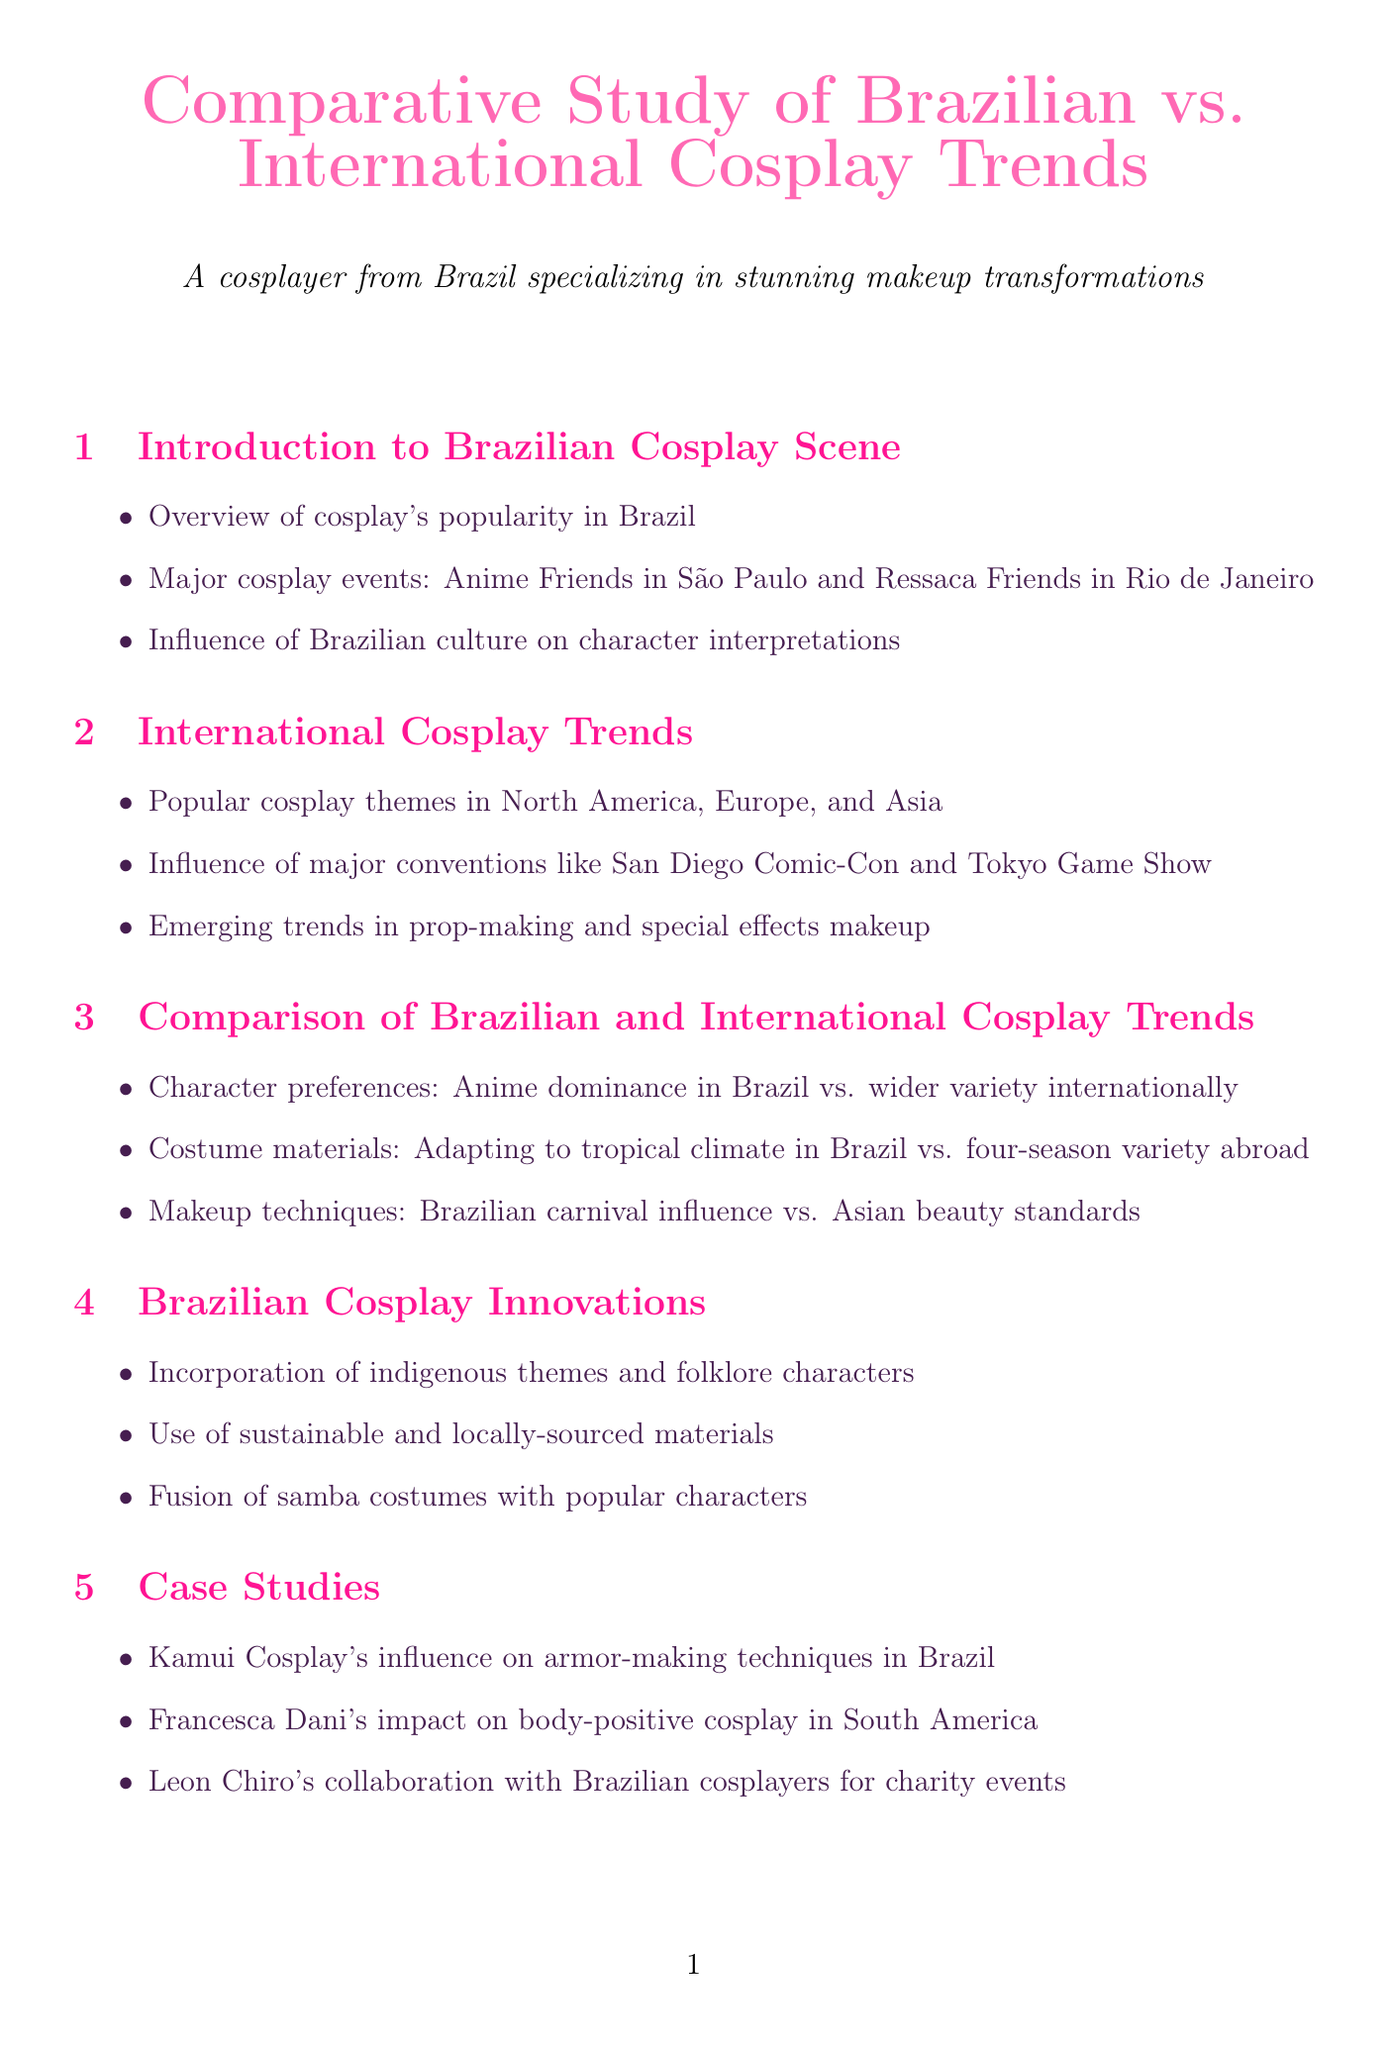What is the main event in São Paulo? The report mentions Anime Friends as the major cosplay event in São Paulo.
Answer: Anime Friends What percentage of Brazilian cosplayers prefer anime characters? The report states that 65% of Brazilian cosplayers prefer anime characters.
Answer: 65% Who is the author of "Makeup Artistry in Cosplay: From Hollywood to São Paulo"? The document lists Carlos Mendez as the author of this publication.
Answer: Carlos Mendez What is the average spend on a cosplay costume in Brazil? The average cost mentioned for a cosplay costume in Brazil is R$500.
Answer: R$500 Which major convention is a significant influence on international cosplay trends? The report highlights San Diego Comic-Con as a key influence on international cosplay trends.
Answer: San Diego Comic-Con What unique cultural element do Brazilian cosplayers incorporate into their costumes? Brazilian cosplayers are noted for incorporating indigenous themes and folklore characters into their costumes.
Answer: Indigenous themes What is the potential for Brazilian comic book characters according to the report? The document suggests there is potential for Brazilian comic book characters in international cosplay scenes.
Answer: Potential for Brazilian comic book characters What challenges are mentioned regarding cosplay materials in Brazil? The key insights suggest challenges in sourcing specific cosplay materials in Brazil.
Answer: Sourcing specific materials What type of makeup products are compared in the document? The report compares SFX makeup products available in Brazil versus those available internationally.
Answer: SFX makeup products 